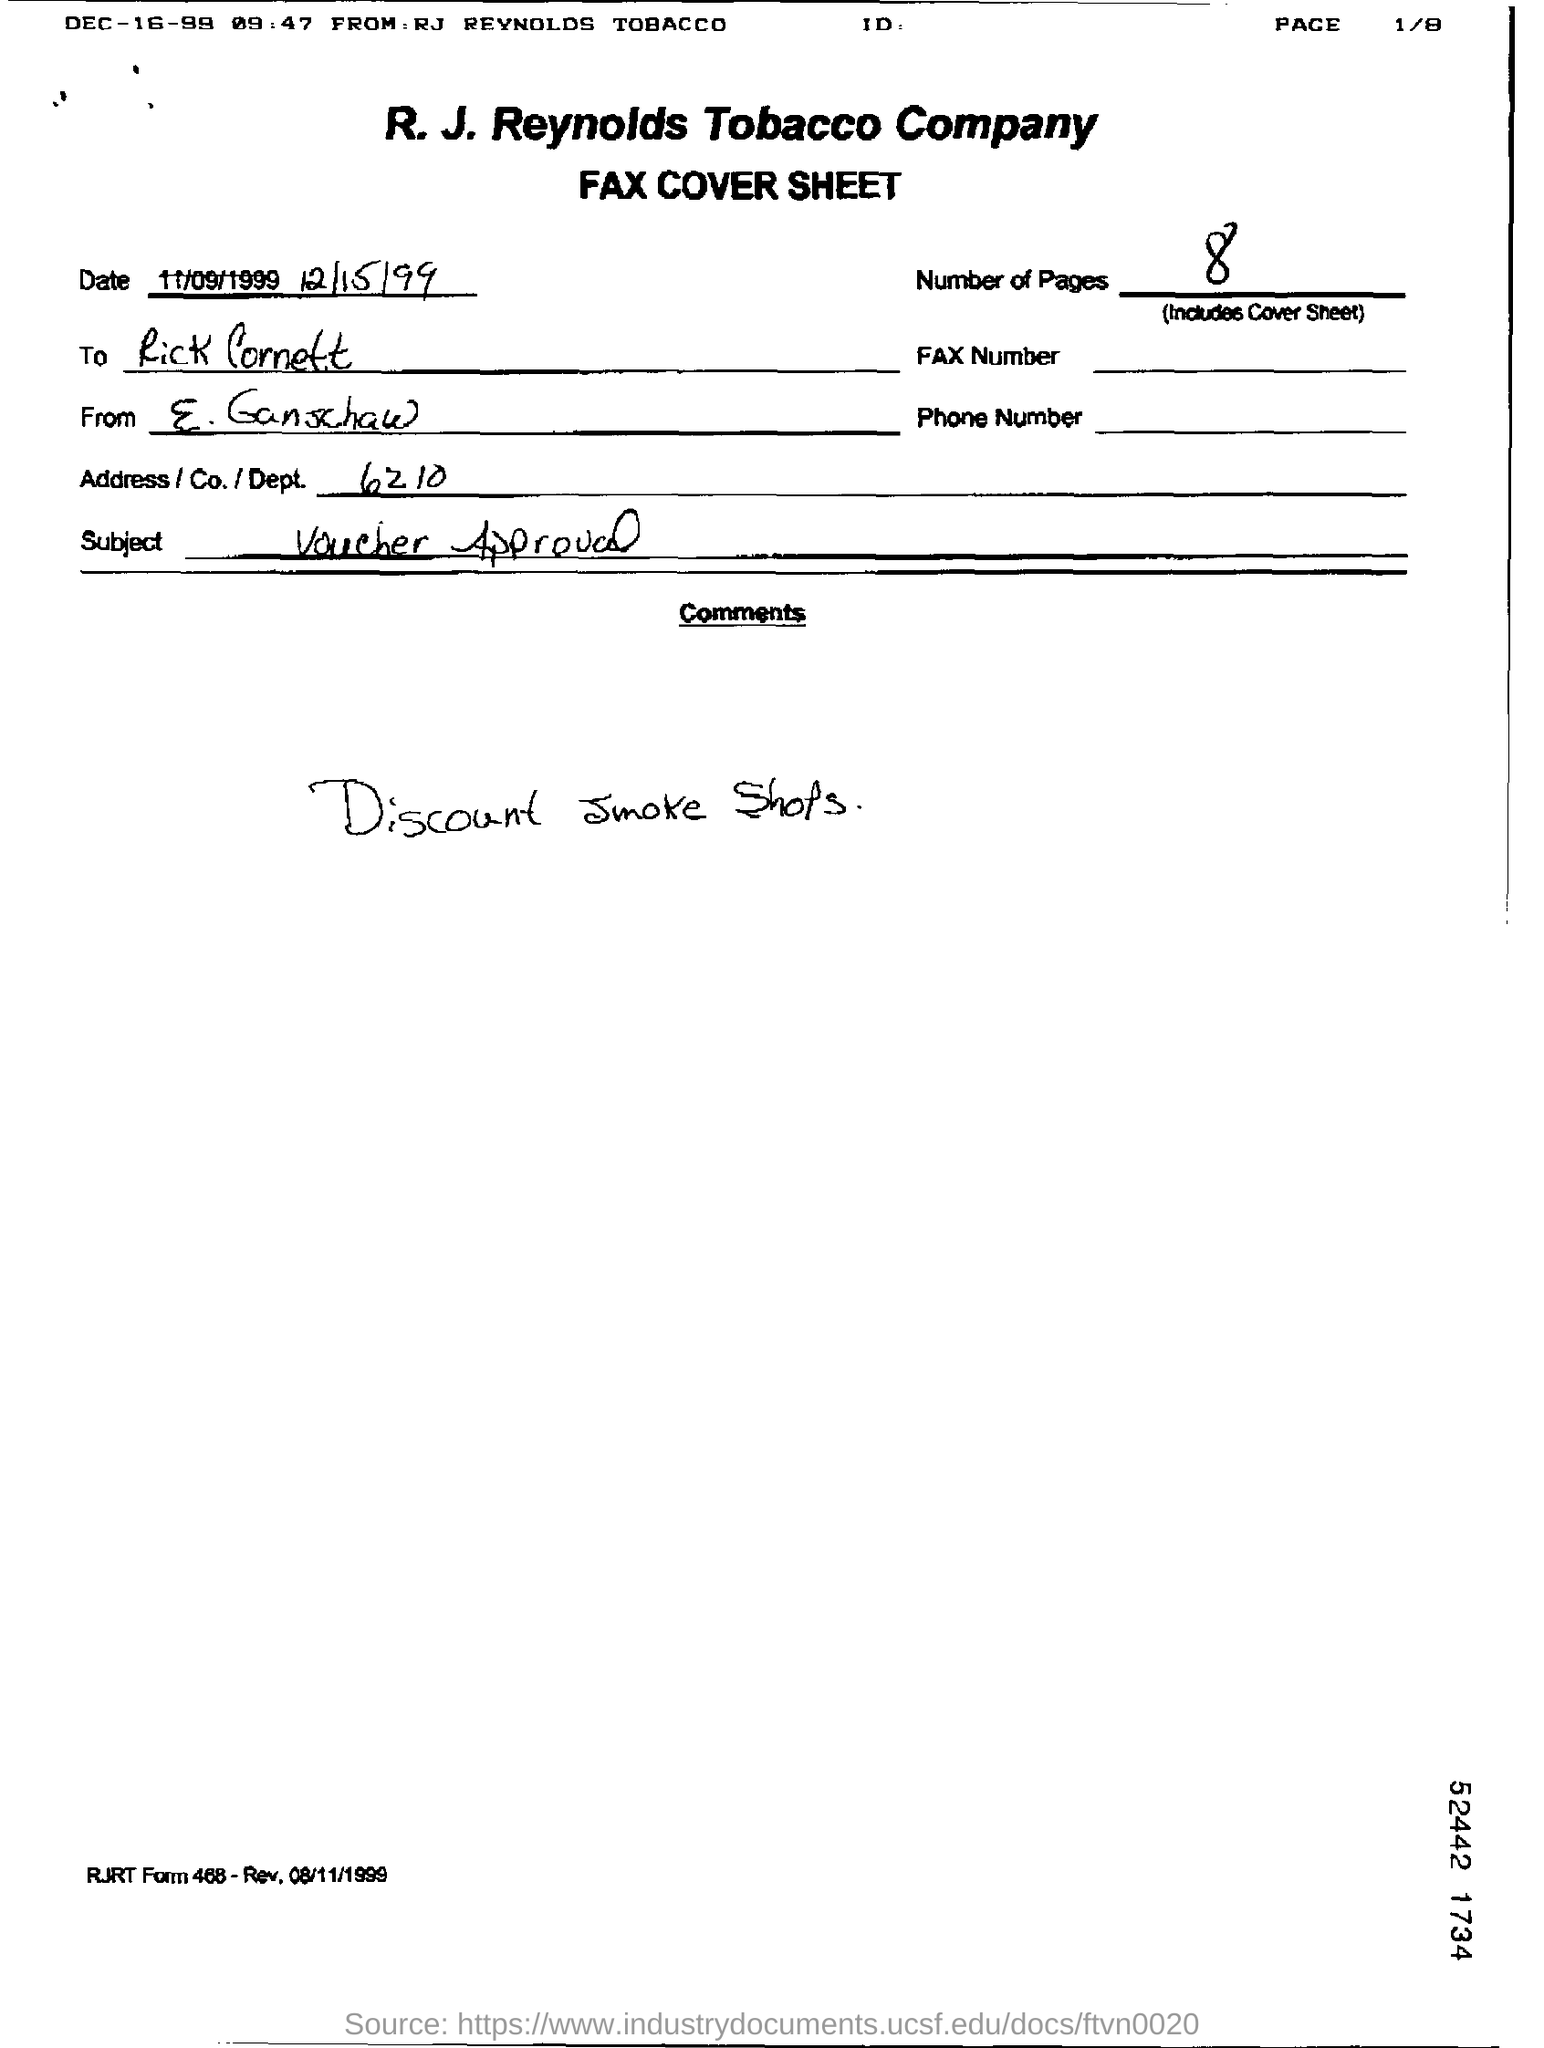What are the Number of pages?
Provide a short and direct response. 8. Who is it "To"?
Your response must be concise. Rick Cornett. Who is it "From"?
Offer a terse response. E. Ganschaw. What is the Address/Co./Dept.?
Your answer should be very brief. 6210. What is the Subject?
Ensure brevity in your answer.  Voucher Approval. 